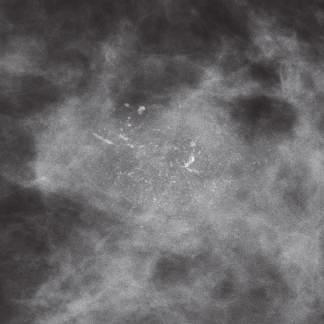s a distinct nuclear inclusion and multiple cytoplasmic inclusions associated with dcis?
Answer the question using a single word or phrase. No 